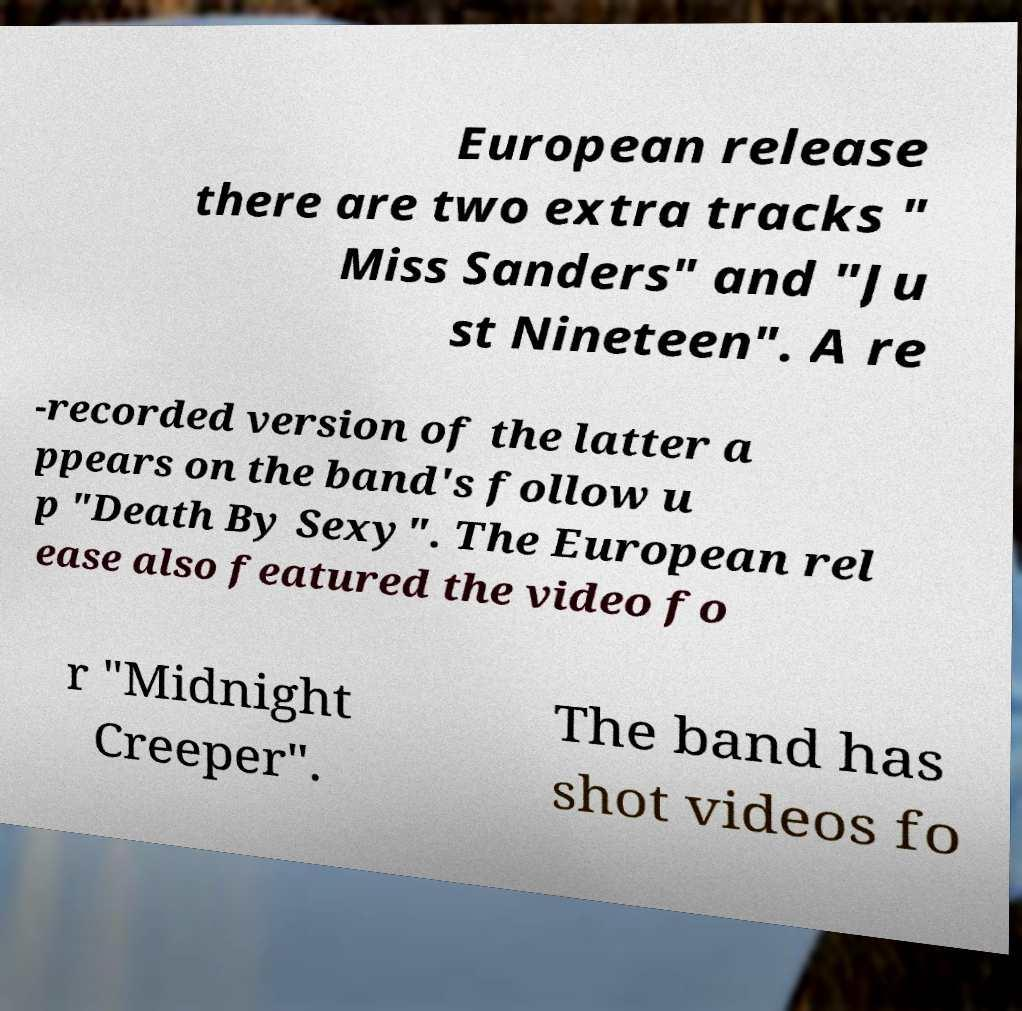I need the written content from this picture converted into text. Can you do that? European release there are two extra tracks " Miss Sanders" and "Ju st Nineteen". A re -recorded version of the latter a ppears on the band's follow u p "Death By Sexy". The European rel ease also featured the video fo r "Midnight Creeper". The band has shot videos fo 